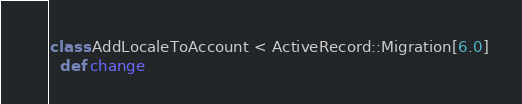Convert code to text. <code><loc_0><loc_0><loc_500><loc_500><_Ruby_>class AddLocaleToAccount < ActiveRecord::Migration[6.0]
  def change</code> 